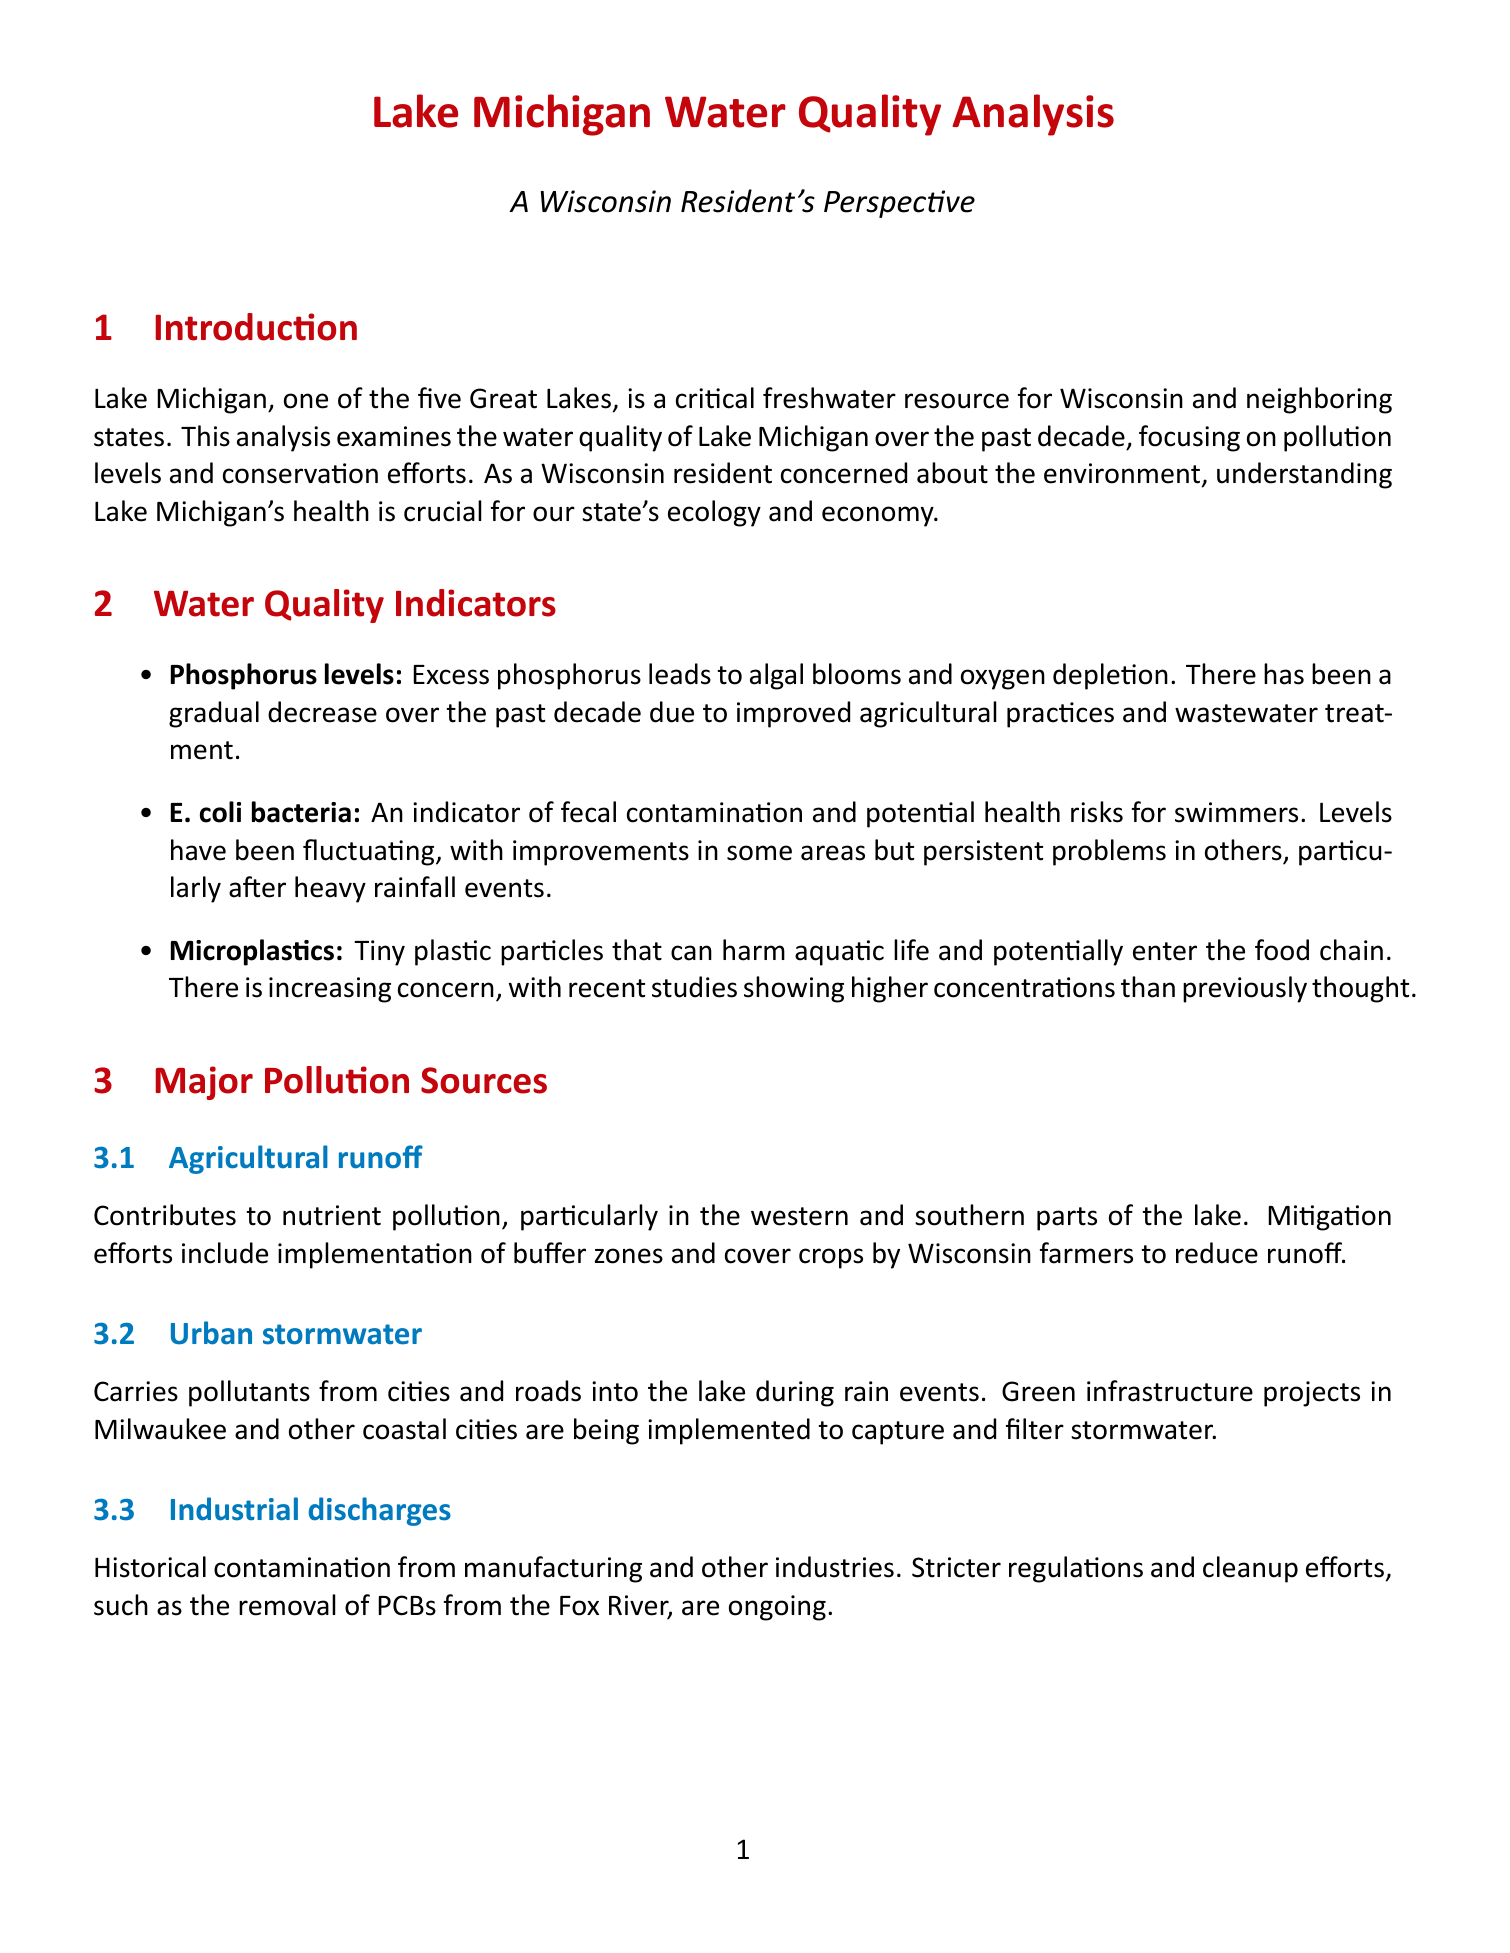What are the three main water quality indicators mentioned? The three main water quality indicators discussed are phosphorus levels, E. coli bacteria, and microplastics.
Answer: phosphorus levels, E. coli bacteria, microplastics What is the trend for phosphorus levels over the past decade? The document states that phosphorus levels have shown a gradual decrease over the past decade due to improved agricultural practices and wastewater treatment.
Answer: gradual decrease What is one of the major pollution sources affecting Lake Michigan? The document lists agricultural runoff, urban stormwater, and industrial discharges as major pollution sources affecting Lake Michigan.
Answer: agricultural runoff What federal program is mentioned as contributing to water quality improvements? The Great Lakes Restoration Initiative is a federal program funding various projects aimed at improving water quality and ecosystem health.
Answer: Great Lakes Restoration Initiative What are the emerging contaminants of concern mentioned in the document? Emerging contaminants of concern in the document include pharmaceuticals and personal care products.
Answer: pharmaceuticals, personal care products What is the impact of climate change as noted in the document? Climate change is described as having potential impacts such as warming waters, changing precipitation patterns, and increased algal blooms.
Answer: warming waters, changing precipitation patterns, algal blooms What type of monitoring programs are mentioned as citizen-led efforts? Citizen-led monitoring programs involve volunteer efforts to collect water quality data and report issues, thus increasing public awareness.
Answer: monitoring programs What is the ongoing concern related to urban development? The document emphasizes persistent challenges from agricultural runoff, urban development, and climate change as ongoing concerns.
Answer: urban development 